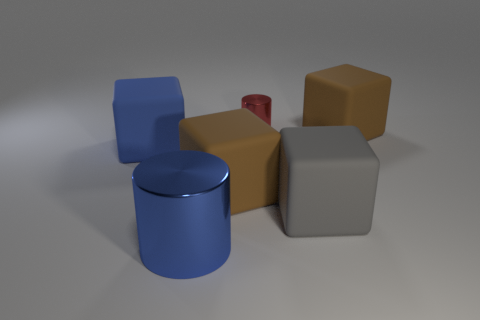Subtract 1 blocks. How many blocks are left? 3 Subtract all purple cubes. Subtract all gray cylinders. How many cubes are left? 4 Add 1 red metallic objects. How many objects exist? 7 Subtract all cubes. How many objects are left? 2 Subtract 0 green cylinders. How many objects are left? 6 Subtract all brown things. Subtract all big blue things. How many objects are left? 2 Add 5 tiny red objects. How many tiny red objects are left? 6 Add 6 gray objects. How many gray objects exist? 7 